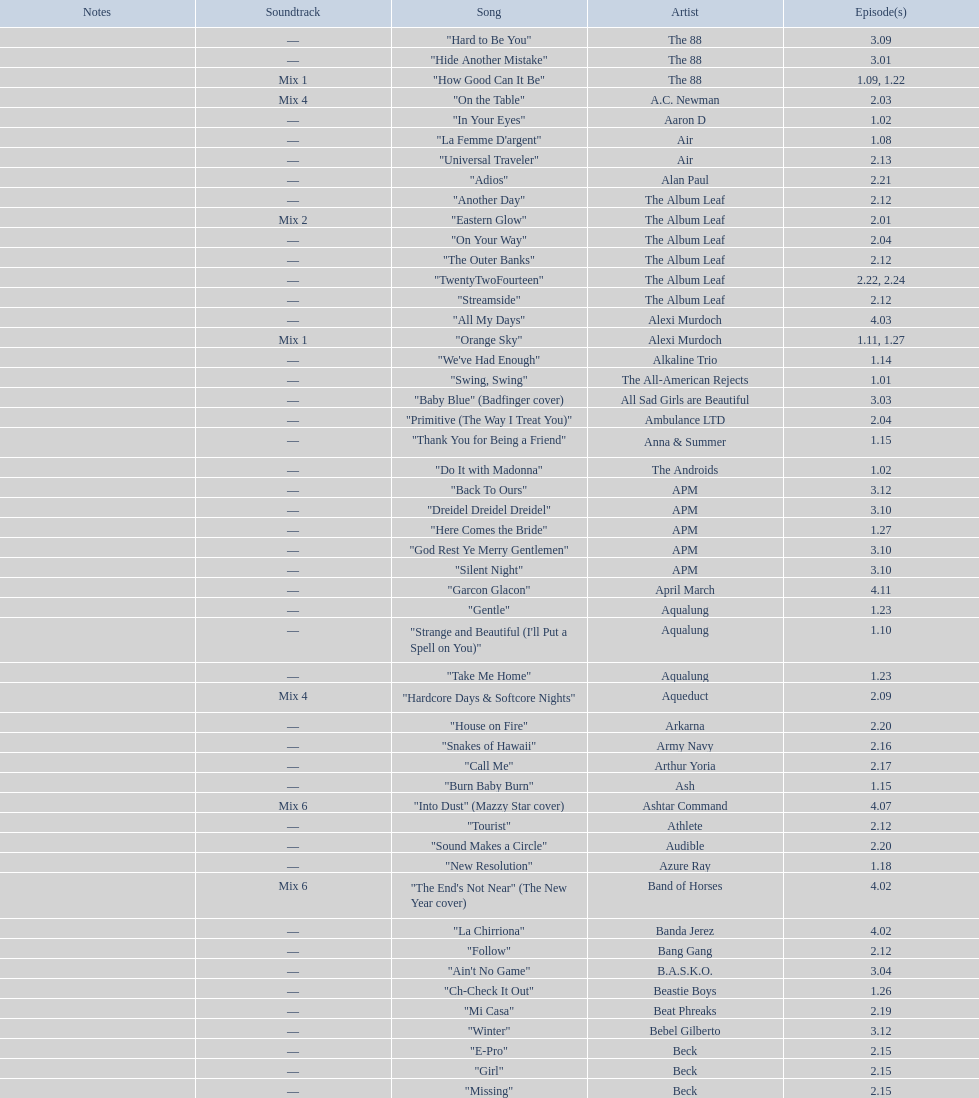How many consecutive songs were by the album leaf? 6. 